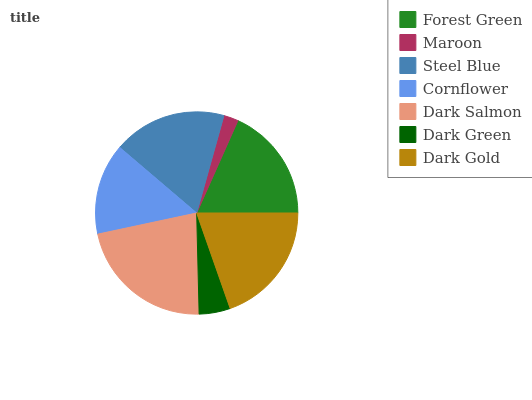Is Maroon the minimum?
Answer yes or no. Yes. Is Dark Salmon the maximum?
Answer yes or no. Yes. Is Steel Blue the minimum?
Answer yes or no. No. Is Steel Blue the maximum?
Answer yes or no. No. Is Steel Blue greater than Maroon?
Answer yes or no. Yes. Is Maroon less than Steel Blue?
Answer yes or no. Yes. Is Maroon greater than Steel Blue?
Answer yes or no. No. Is Steel Blue less than Maroon?
Answer yes or no. No. Is Steel Blue the high median?
Answer yes or no. Yes. Is Steel Blue the low median?
Answer yes or no. Yes. Is Forest Green the high median?
Answer yes or no. No. Is Dark Gold the low median?
Answer yes or no. No. 